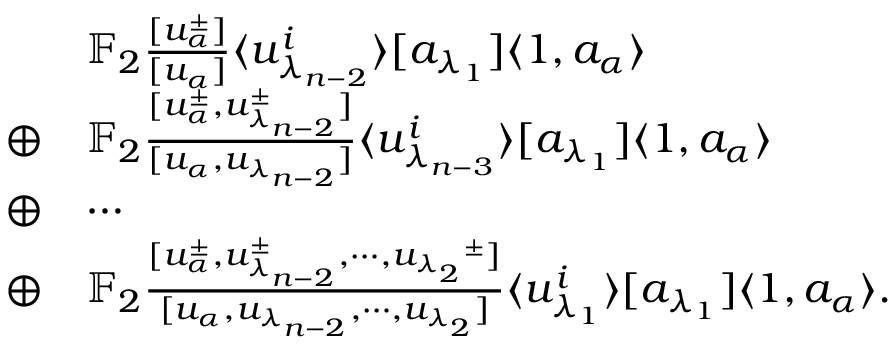<formula> <loc_0><loc_0><loc_500><loc_500>\begin{array} { r l } & { \mathbb { F } _ { 2 } \frac { [ u _ { \alpha } ^ { \pm } ] } { [ u _ { \alpha } ] } \langle u _ { \lambda _ { n - 2 } } ^ { i } \rangle [ a _ { \lambda _ { 1 } } ] \langle 1 , a _ { \alpha } \rangle } \\ { \oplus } & { \mathbb { F } _ { 2 } \frac { [ u _ { \alpha } ^ { \pm } , u _ { \lambda _ { n - 2 } } ^ { \pm } ] } { [ u _ { \alpha } , u _ { \lambda _ { n - 2 } } ] } \langle u _ { \lambda _ { n - 3 } } ^ { i } \rangle [ a _ { \lambda _ { 1 } } ] \langle 1 , a _ { \alpha } \rangle } \\ { \oplus } & { \cdots } \\ { \oplus } & { \mathbb { F } _ { 2 } \frac { [ u _ { \alpha } ^ { \pm } , u _ { \lambda _ { n - 2 } } ^ { \pm } , \cdots , { u _ { \lambda _ { 2 } } } ^ { \pm } ] } { [ u _ { \alpha } , u _ { \lambda _ { n - 2 } } , \cdots , u _ { \lambda _ { 2 } } ] } \langle u _ { \lambda _ { 1 } } ^ { i } \rangle [ a _ { \lambda _ { 1 } } ] \langle 1 , a _ { \alpha } \rangle . } \end{array}</formula> 